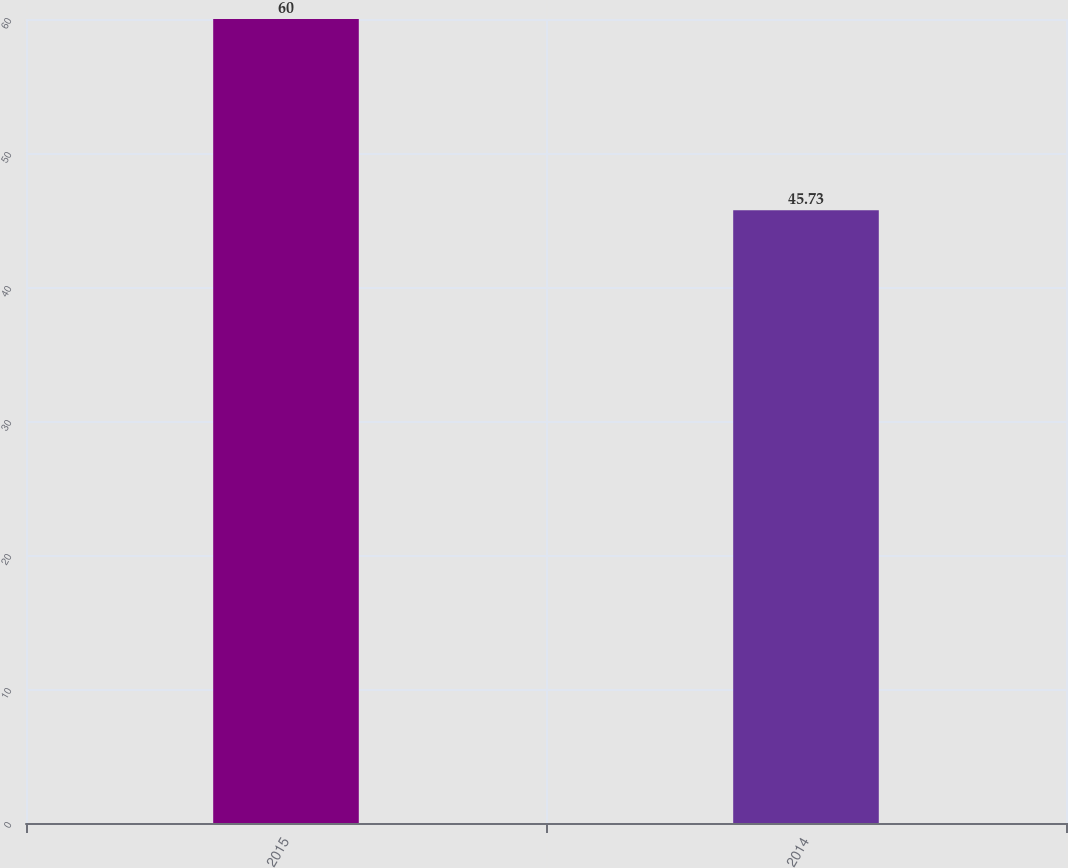Convert chart to OTSL. <chart><loc_0><loc_0><loc_500><loc_500><bar_chart><fcel>2015<fcel>2014<nl><fcel>60<fcel>45.73<nl></chart> 